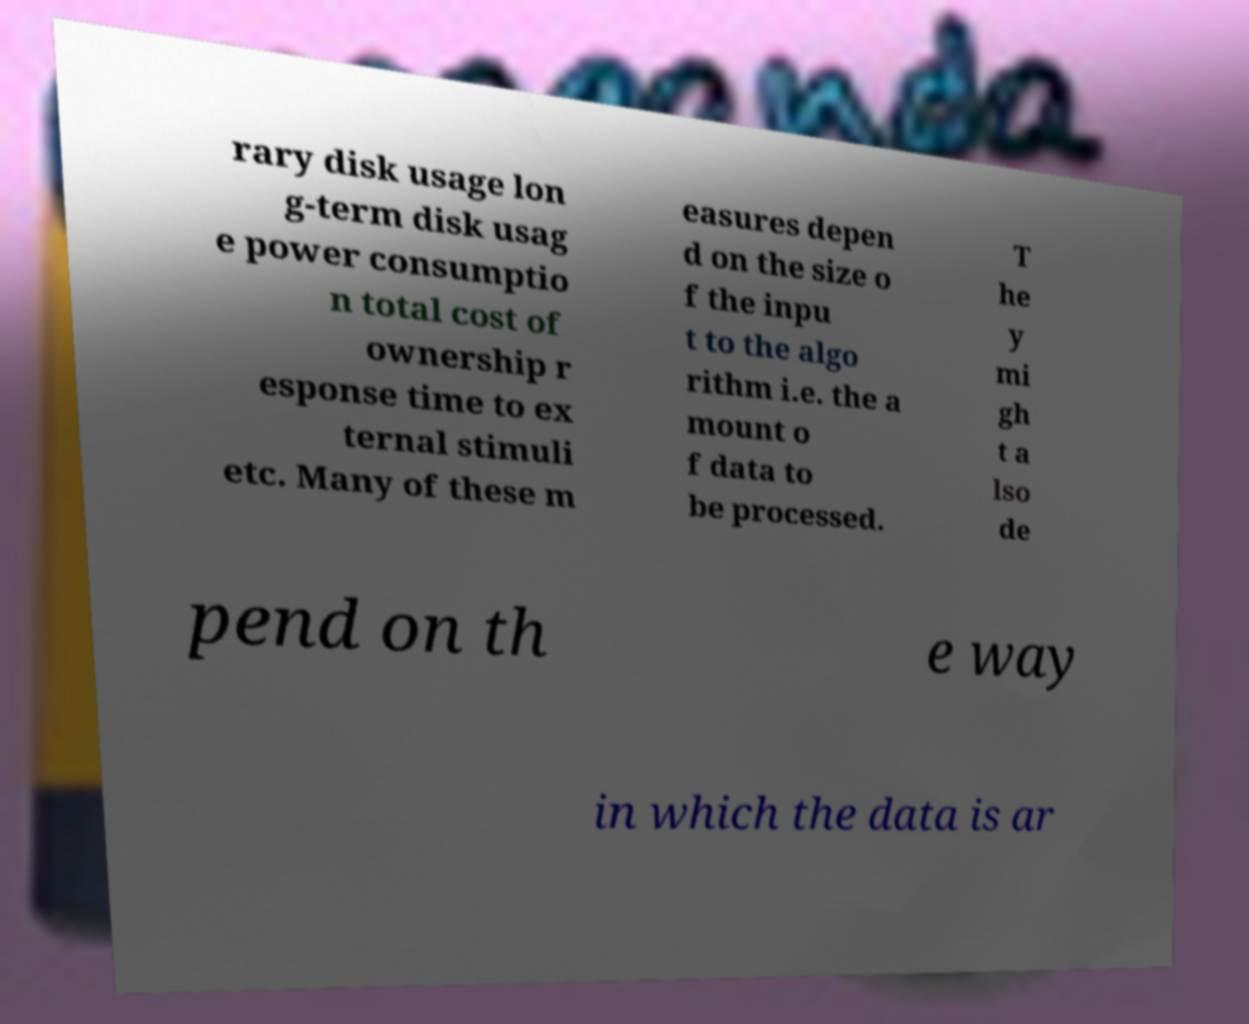Can you accurately transcribe the text from the provided image for me? rary disk usage lon g-term disk usag e power consumptio n total cost of ownership r esponse time to ex ternal stimuli etc. Many of these m easures depen d on the size o f the inpu t to the algo rithm i.e. the a mount o f data to be processed. T he y mi gh t a lso de pend on th e way in which the data is ar 